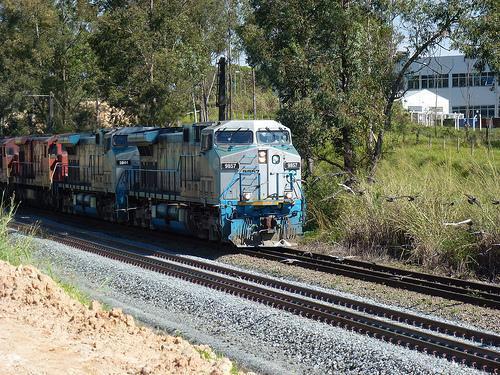How many trains are shown?
Give a very brief answer. 1. How many tracks are there?
Give a very brief answer. 2. How many motors are driving near the train?
Give a very brief answer. 0. 